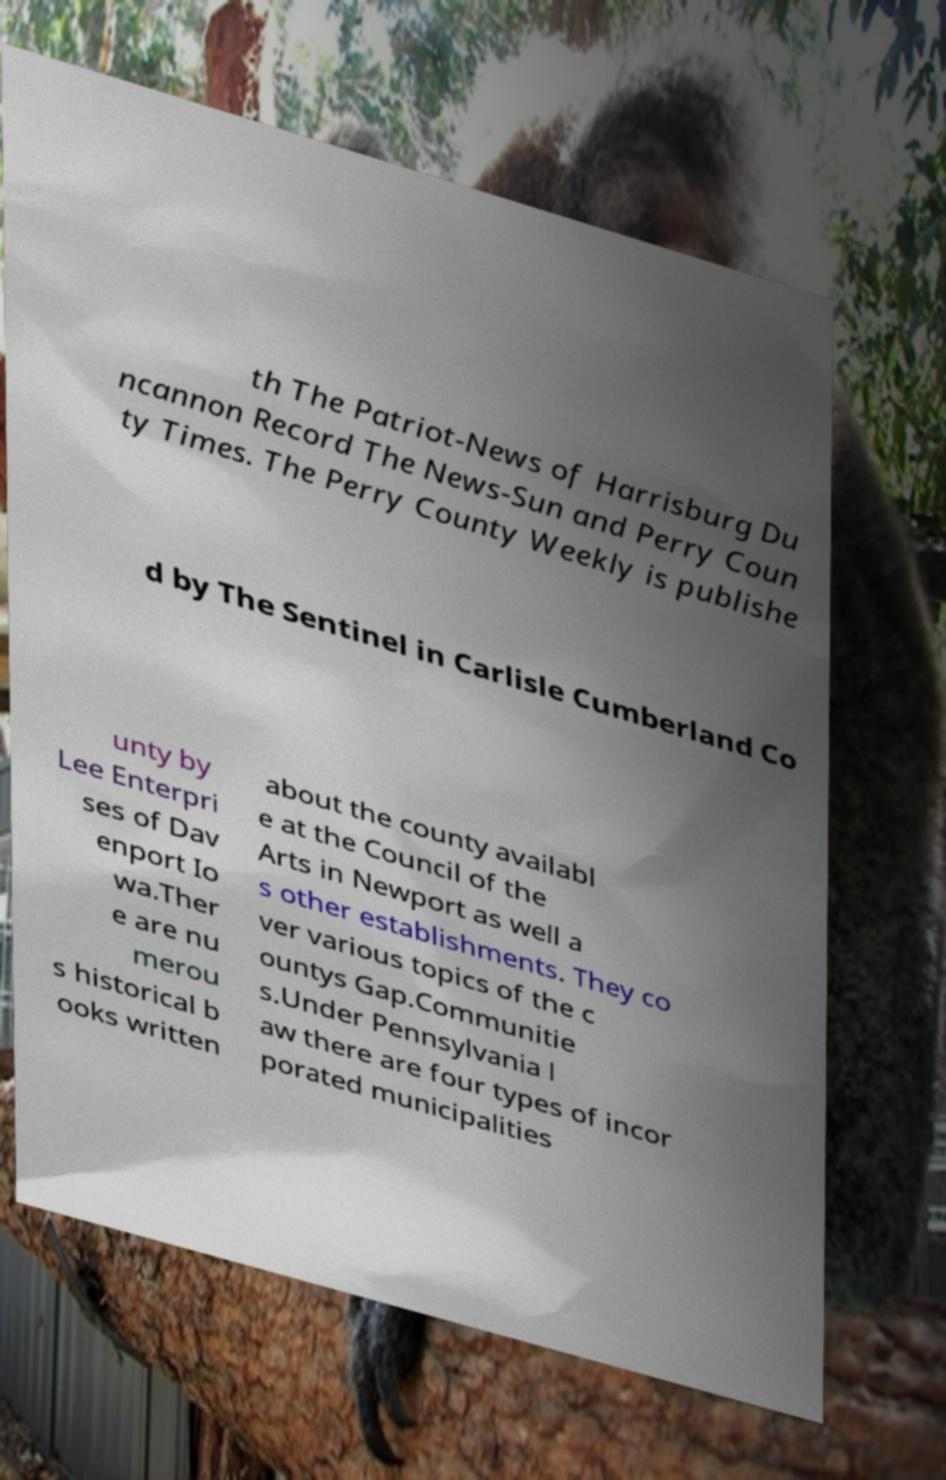I need the written content from this picture converted into text. Can you do that? th The Patriot-News of Harrisburg Du ncannon Record The News-Sun and Perry Coun ty Times. The Perry County Weekly is publishe d by The Sentinel in Carlisle Cumberland Co unty by Lee Enterpri ses of Dav enport Io wa.Ther e are nu merou s historical b ooks written about the county availabl e at the Council of the Arts in Newport as well a s other establishments. They co ver various topics of the c ountys Gap.Communitie s.Under Pennsylvania l aw there are four types of incor porated municipalities 